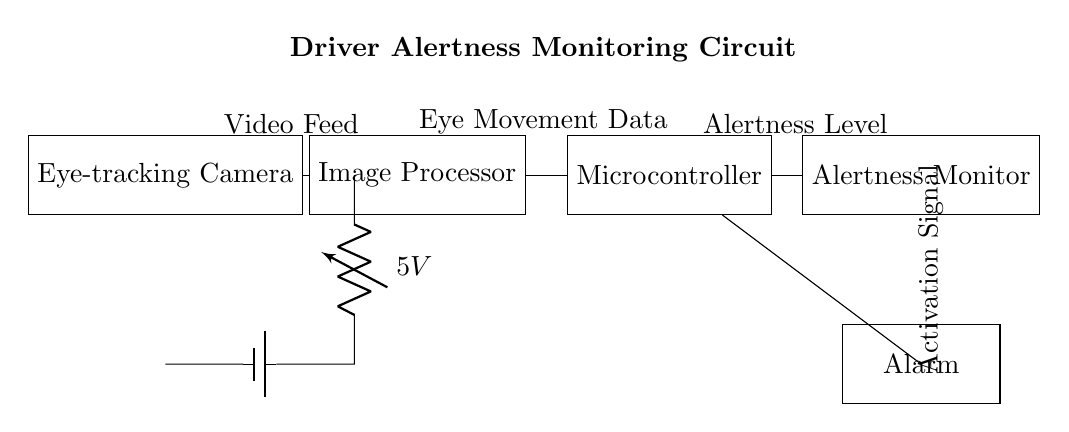What is the main purpose of this circuit? The main purpose is to monitor driver alertness based on eye-tracking data, ensuring driver safety.
Answer: Monitoring driver alertness What is the voltage source for this circuit? The voltage source shown in the circuit is a battery labeled as 5 volts.
Answer: 5 volts Which component receives data from the eye-tracking camera? The component that receives data from the eye-tracking camera is the image processor, as indicated by the direct connection from the camera.
Answer: Image processor What is the final output of this circuit? The final output of this circuit is the alarm, which activates based on the alertness level determined by the microcontroller.
Answer: Alarm How many main components are involved in this driver alertness monitoring circuit? There are four main components: Eye-tracking Camera, Image Processor, Microcontroller, and Alertness Monitor.
Answer: Four What type of data does the microcontroller handle? The microcontroller handles eye movement data, as indicated by its connection to the image processor and the flow of data.
Answer: Eye movement data What component provides the activation signal to the alarm? The component providing the activation signal to the alarm is the microcontroller, which triggers the alarm based on alertness level.
Answer: Microcontroller 